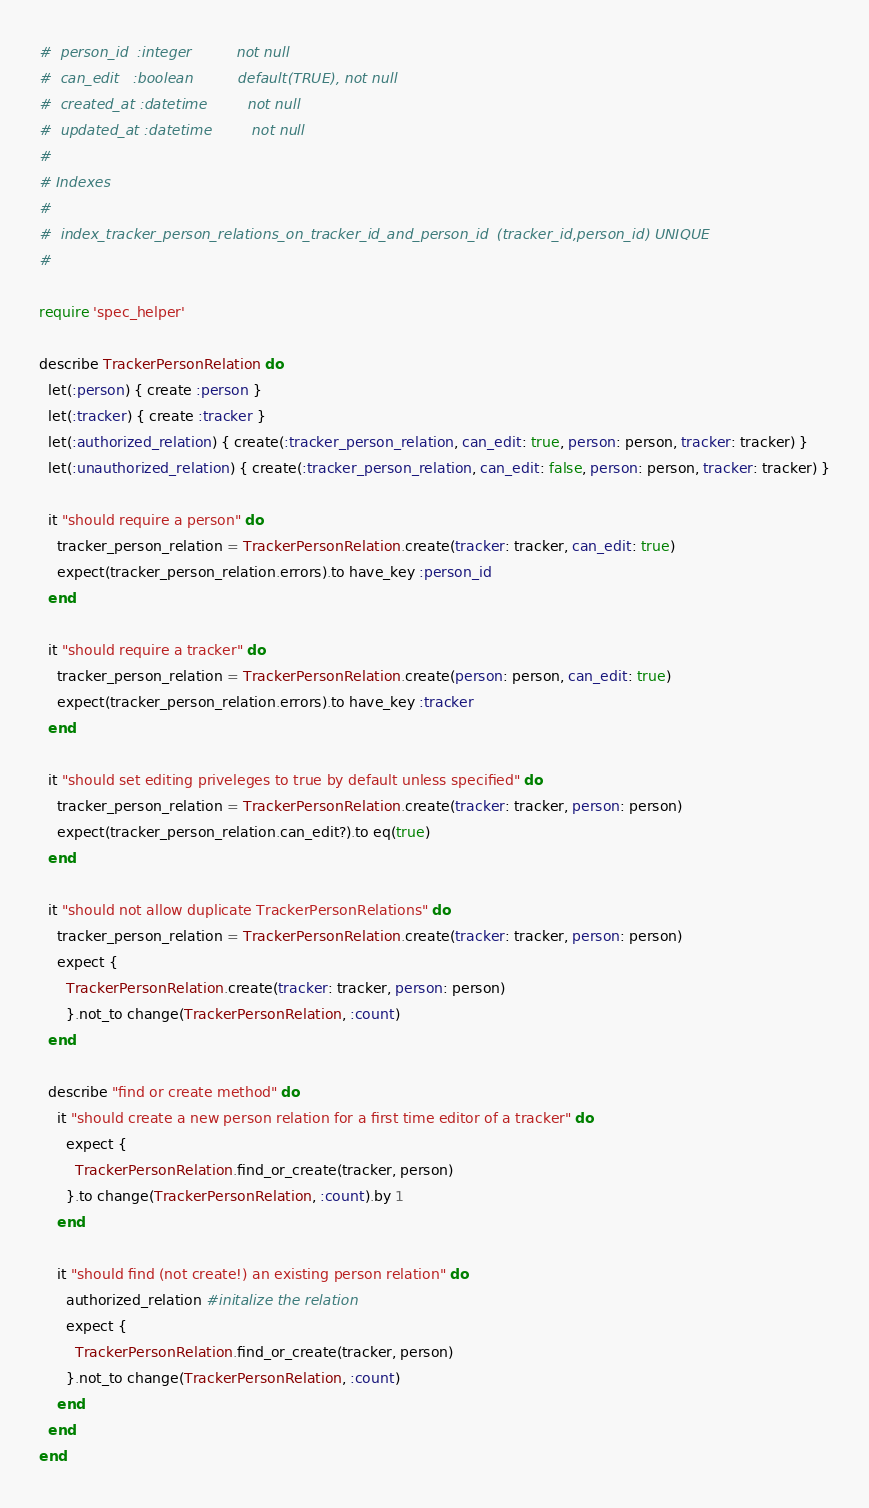<code> <loc_0><loc_0><loc_500><loc_500><_Ruby_>#  person_id  :integer          not null
#  can_edit   :boolean          default(TRUE), not null
#  created_at :datetime         not null
#  updated_at :datetime         not null
#
# Indexes
#
#  index_tracker_person_relations_on_tracker_id_and_person_id  (tracker_id,person_id) UNIQUE
#

require 'spec_helper'

describe TrackerPersonRelation do
  let(:person) { create :person }
  let(:tracker) { create :tracker }
  let(:authorized_relation) { create(:tracker_person_relation, can_edit: true, person: person, tracker: tracker) }
  let(:unauthorized_relation) { create(:tracker_person_relation, can_edit: false, person: person, tracker: tracker) }

  it "should require a person" do
    tracker_person_relation = TrackerPersonRelation.create(tracker: tracker, can_edit: true)
    expect(tracker_person_relation.errors).to have_key :person_id
  end

  it "should require a tracker" do
    tracker_person_relation = TrackerPersonRelation.create(person: person, can_edit: true)
    expect(tracker_person_relation.errors).to have_key :tracker
  end

  it "should set editing priveleges to true by default unless specified" do
    tracker_person_relation = TrackerPersonRelation.create(tracker: tracker, person: person)
    expect(tracker_person_relation.can_edit?).to eq(true)
  end

  it "should not allow duplicate TrackerPersonRelations" do
    tracker_person_relation = TrackerPersonRelation.create(tracker: tracker, person: person)
    expect {
      TrackerPersonRelation.create(tracker: tracker, person: person)
      }.not_to change(TrackerPersonRelation, :count)
  end

  describe "find or create method" do
    it "should create a new person relation for a first time editor of a tracker" do
      expect {
        TrackerPersonRelation.find_or_create(tracker, person)
      }.to change(TrackerPersonRelation, :count).by 1
    end

    it "should find (not create!) an existing person relation" do
      authorized_relation #initalize the relation
      expect {
        TrackerPersonRelation.find_or_create(tracker, person)
      }.not_to change(TrackerPersonRelation, :count)
    end
  end
end
</code> 